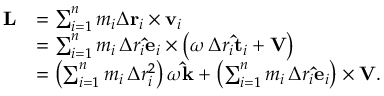Convert formula to latex. <formula><loc_0><loc_0><loc_500><loc_500>{ \begin{array} { r l } { L } & { = \sum _ { i = 1 } ^ { n } m _ { i } \Delta r _ { i } \times v _ { i } } \\ & { = \sum _ { i = 1 } ^ { n } m _ { i } \, \Delta r _ { i } \hat { e } _ { i } \times \left ( \omega \, \Delta r _ { i } \hat { t } _ { i } + V \right ) } \\ & { = \left ( \sum _ { i = 1 } ^ { n } m _ { i } \, \Delta r _ { i } ^ { 2 } \right ) \omega \hat { k } + \left ( \sum _ { i = 1 } ^ { n } m _ { i } \, \Delta r _ { i } \hat { e } _ { i } \right ) \times V . } \end{array} }</formula> 